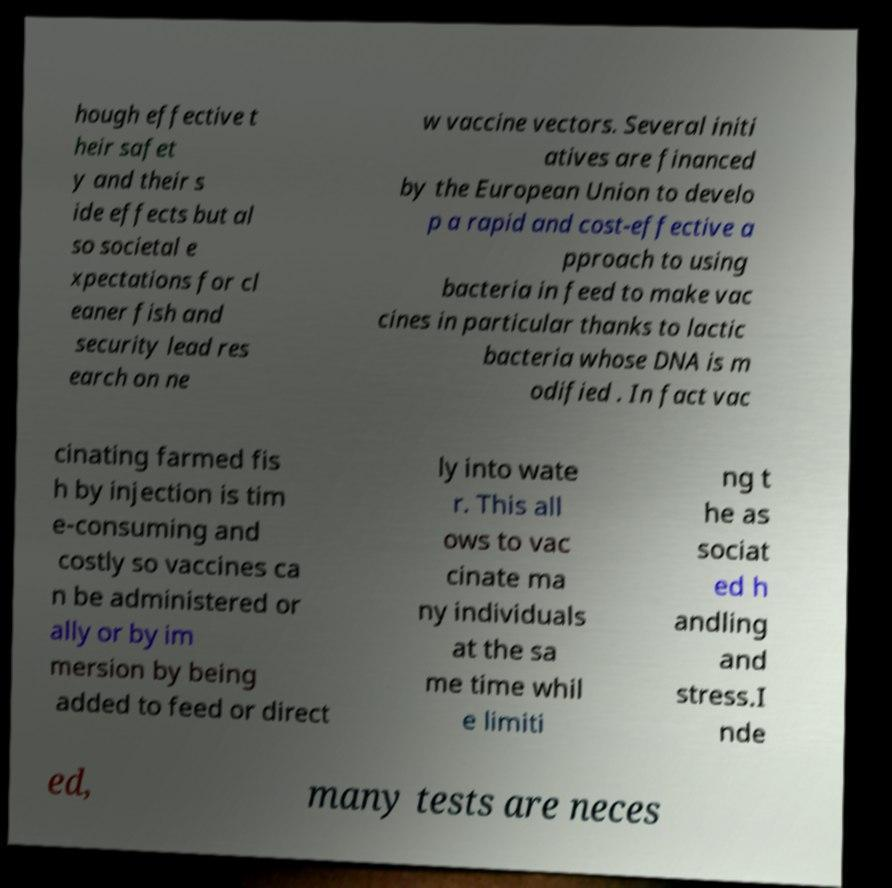Could you extract and type out the text from this image? hough effective t heir safet y and their s ide effects but al so societal e xpectations for cl eaner fish and security lead res earch on ne w vaccine vectors. Several initi atives are financed by the European Union to develo p a rapid and cost-effective a pproach to using bacteria in feed to make vac cines in particular thanks to lactic bacteria whose DNA is m odified . In fact vac cinating farmed fis h by injection is tim e-consuming and costly so vaccines ca n be administered or ally or by im mersion by being added to feed or direct ly into wate r. This all ows to vac cinate ma ny individuals at the sa me time whil e limiti ng t he as sociat ed h andling and stress.I nde ed, many tests are neces 